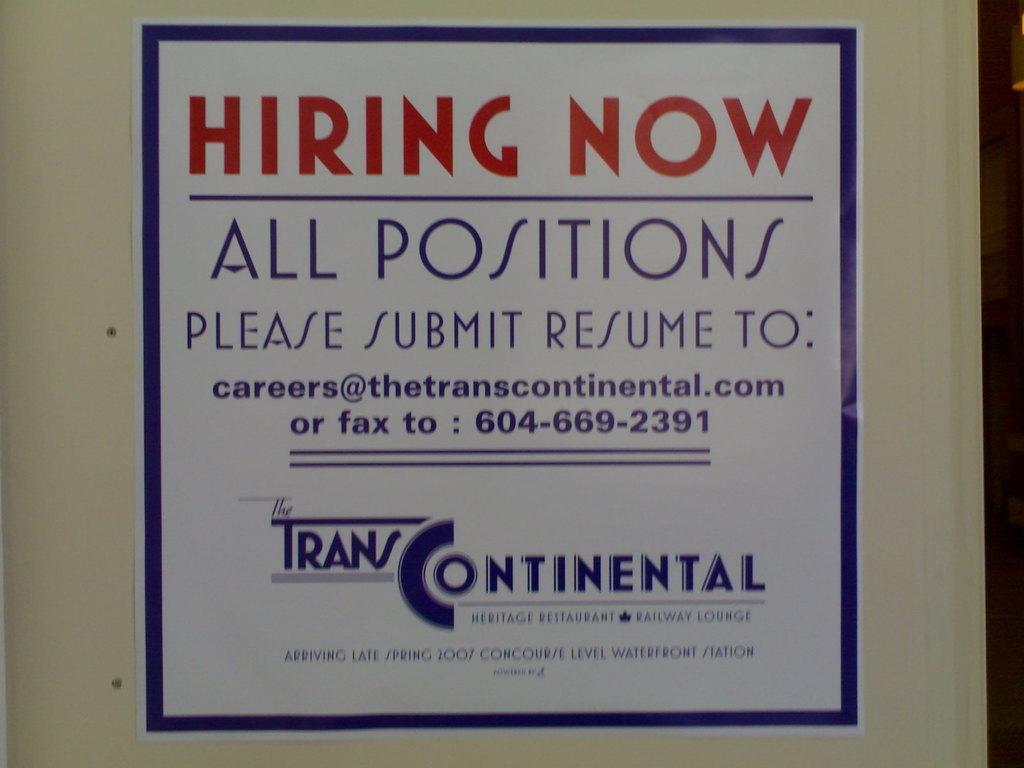Can you describe this image briefly? In this picture I can see a poster on which I can see something written on it and a blue color border. This poster is on a white color wall. 